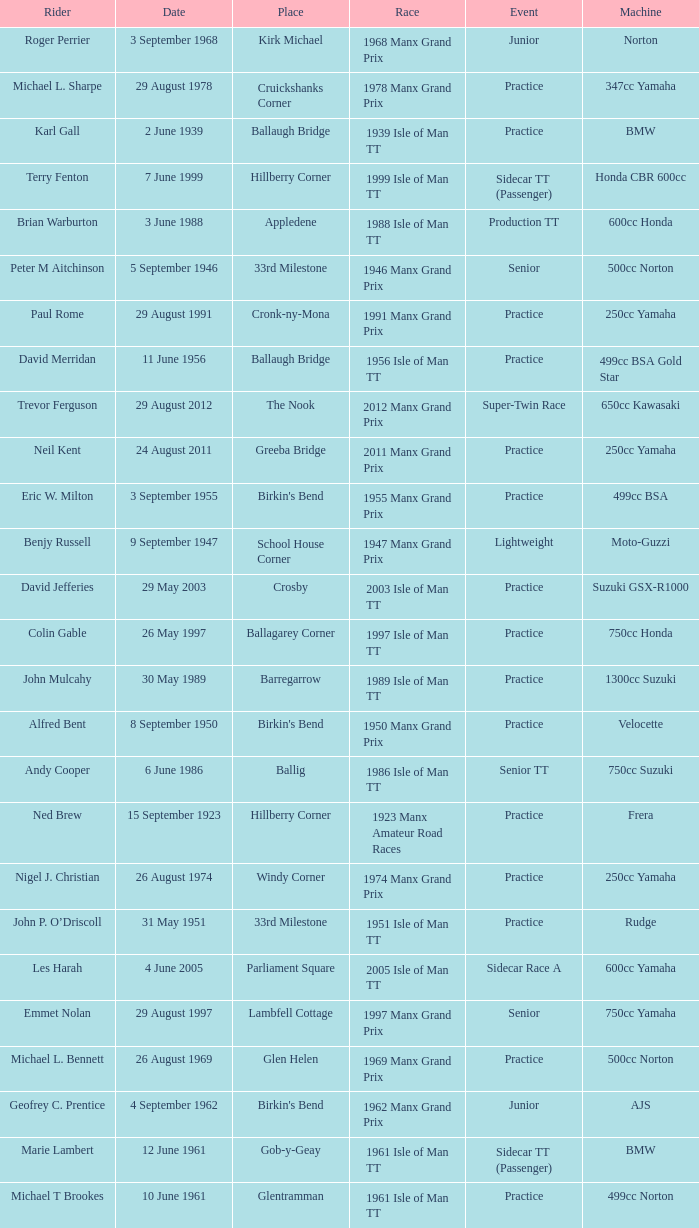Where was the 249cc Yamaha? Glentramman. 